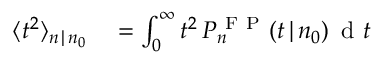<formula> <loc_0><loc_0><loc_500><loc_500>\begin{array} { r l } { \langle t ^ { 2 } \rangle _ { n \, | \, n _ { 0 } } } & = \int _ { 0 } ^ { \infty } t ^ { 2 } \, P _ { n } ^ { F P } ( t \, | \, n _ { 0 } ) \, d t } \end{array}</formula> 